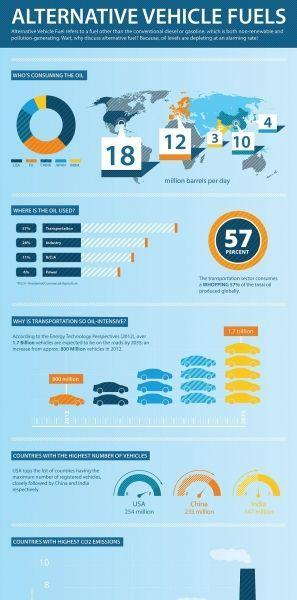How many cars are shown in the infographic?
Answer the question with a short phrase. 15 How many yellow cars are shown? 5 